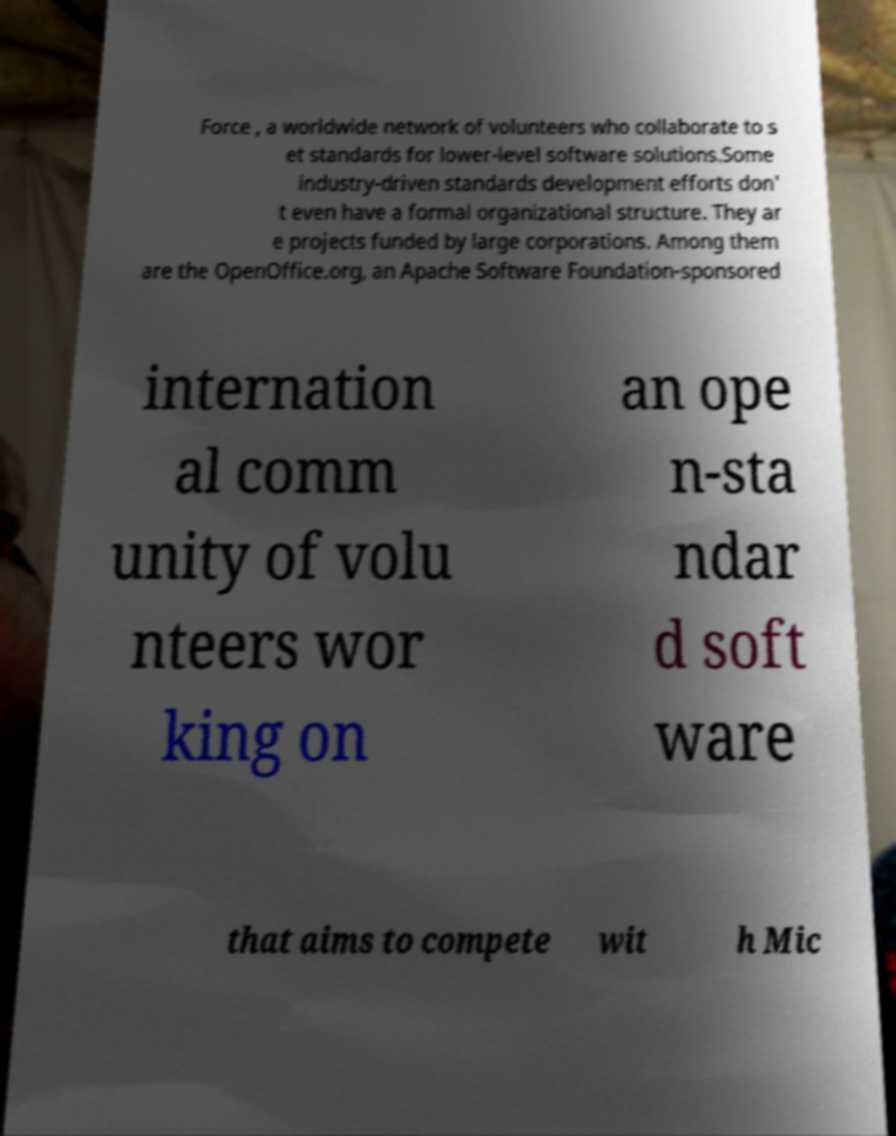There's text embedded in this image that I need extracted. Can you transcribe it verbatim? Force , a worldwide network of volunteers who collaborate to s et standards for lower-level software solutions.Some industry-driven standards development efforts don' t even have a formal organizational structure. They ar e projects funded by large corporations. Among them are the OpenOffice.org, an Apache Software Foundation-sponsored internation al comm unity of volu nteers wor king on an ope n-sta ndar d soft ware that aims to compete wit h Mic 